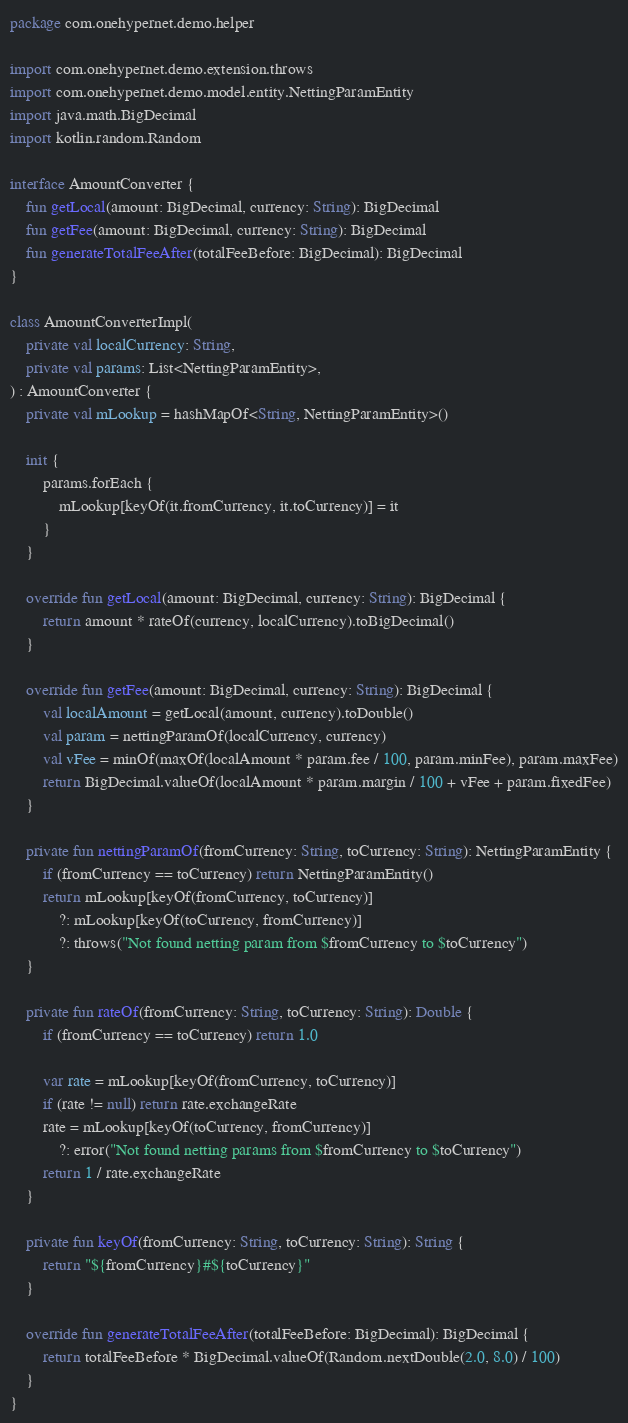Convert code to text. <code><loc_0><loc_0><loc_500><loc_500><_Kotlin_>package com.onehypernet.demo.helper

import com.onehypernet.demo.extension.throws
import com.onehypernet.demo.model.entity.NettingParamEntity
import java.math.BigDecimal
import kotlin.random.Random

interface AmountConverter {
    fun getLocal(amount: BigDecimal, currency: String): BigDecimal
    fun getFee(amount: BigDecimal, currency: String): BigDecimal
    fun generateTotalFeeAfter(totalFeeBefore: BigDecimal): BigDecimal
}

class AmountConverterImpl(
    private val localCurrency: String,
    private val params: List<NettingParamEntity>,
) : AmountConverter {
    private val mLookup = hashMapOf<String, NettingParamEntity>()

    init {
        params.forEach {
            mLookup[keyOf(it.fromCurrency, it.toCurrency)] = it
        }
    }

    override fun getLocal(amount: BigDecimal, currency: String): BigDecimal {
        return amount * rateOf(currency, localCurrency).toBigDecimal()
    }

    override fun getFee(amount: BigDecimal, currency: String): BigDecimal {
        val localAmount = getLocal(amount, currency).toDouble()
        val param = nettingParamOf(localCurrency, currency)
        val vFee = minOf(maxOf(localAmount * param.fee / 100, param.minFee), param.maxFee)
        return BigDecimal.valueOf(localAmount * param.margin / 100 + vFee + param.fixedFee)
    }

    private fun nettingParamOf(fromCurrency: String, toCurrency: String): NettingParamEntity {
        if (fromCurrency == toCurrency) return NettingParamEntity()
        return mLookup[keyOf(fromCurrency, toCurrency)]
            ?: mLookup[keyOf(toCurrency, fromCurrency)]
            ?: throws("Not found netting param from $fromCurrency to $toCurrency")
    }

    private fun rateOf(fromCurrency: String, toCurrency: String): Double {
        if (fromCurrency == toCurrency) return 1.0

        var rate = mLookup[keyOf(fromCurrency, toCurrency)]
        if (rate != null) return rate.exchangeRate
        rate = mLookup[keyOf(toCurrency, fromCurrency)]
            ?: error("Not found netting params from $fromCurrency to $toCurrency")
        return 1 / rate.exchangeRate
    }

    private fun keyOf(fromCurrency: String, toCurrency: String): String {
        return "${fromCurrency}#${toCurrency}"
    }

    override fun generateTotalFeeAfter(totalFeeBefore: BigDecimal): BigDecimal {
        return totalFeeBefore * BigDecimal.valueOf(Random.nextDouble(2.0, 8.0) / 100)
    }
}</code> 